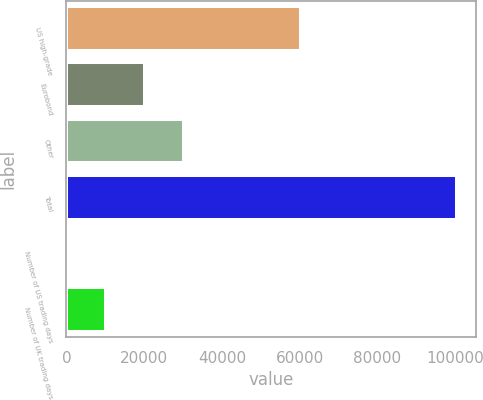Convert chart. <chart><loc_0><loc_0><loc_500><loc_500><bar_chart><fcel>US high-grade<fcel>Eurobond<fcel>Other<fcel>Total<fcel>Number of US trading days<fcel>Number of UK trading days<nl><fcel>60387<fcel>20141.2<fcel>30179.8<fcel>100450<fcel>64<fcel>10102.6<nl></chart> 